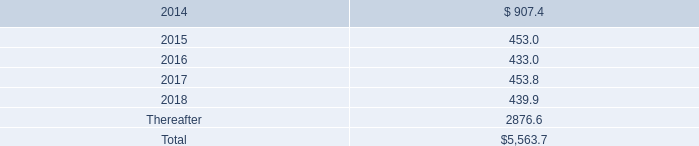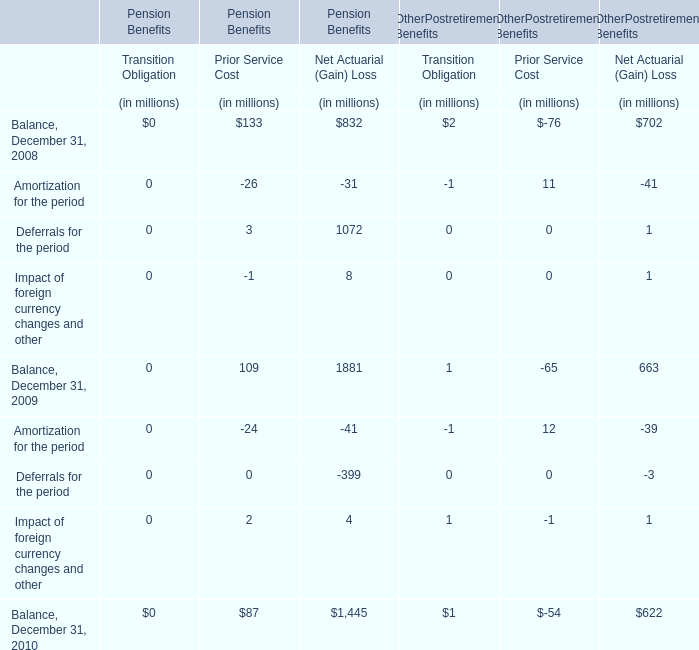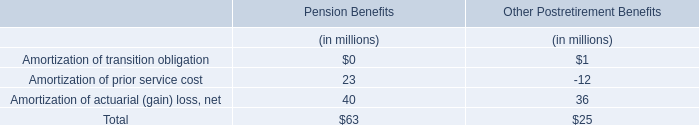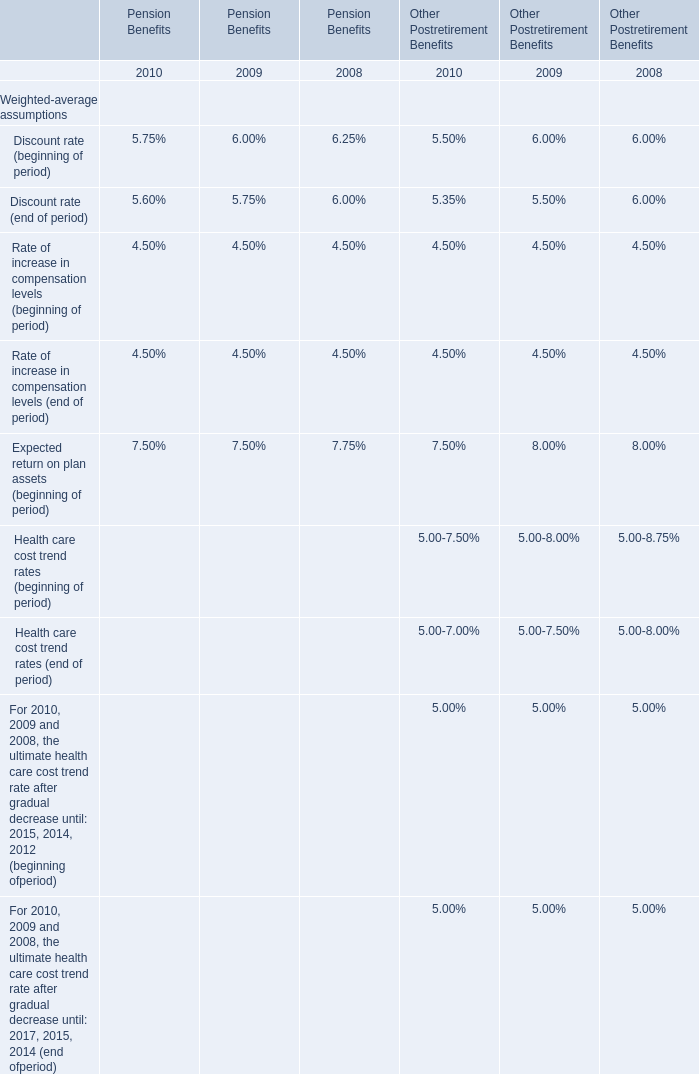Which year is Balance for Net Actuarial (Gain) in terms of Pension Benefits on December 31 the highest? 
Answer: 2009. 